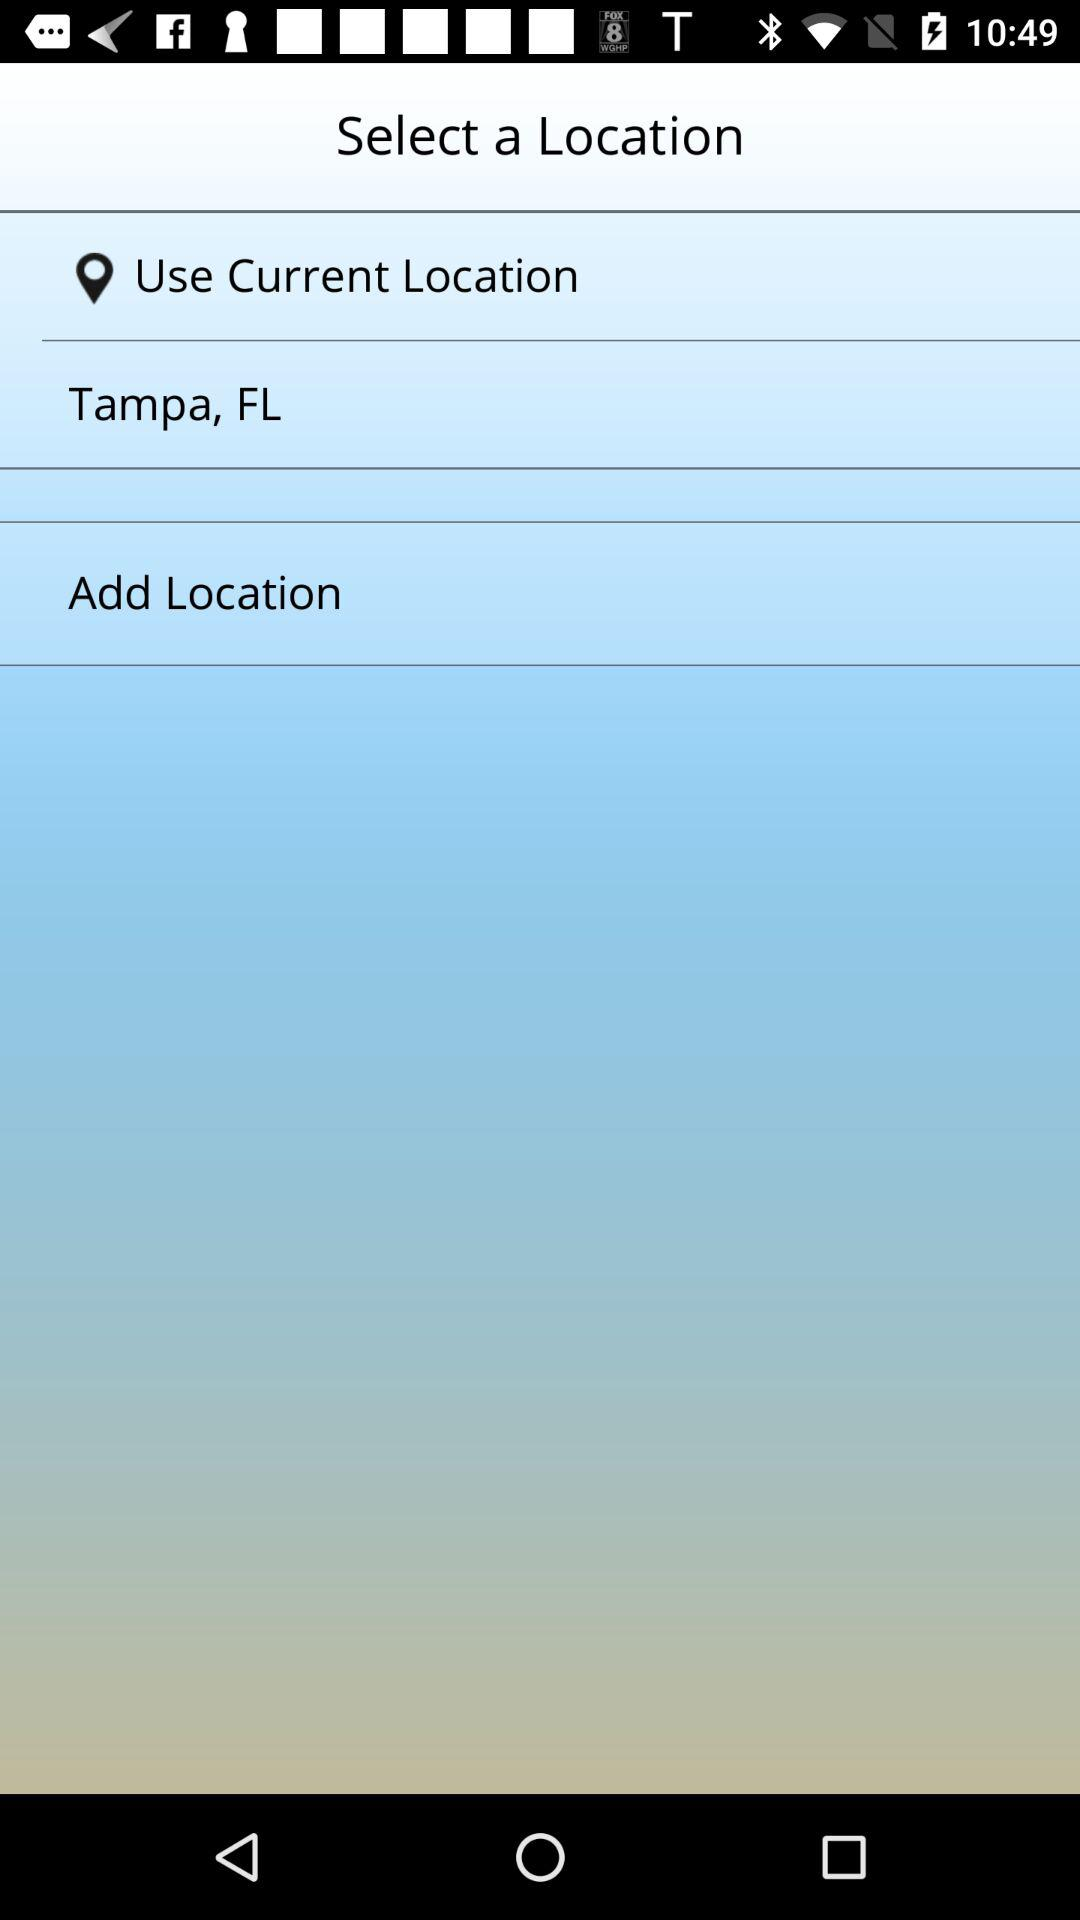What is the mentioned city? The mentioned city is Tampa. 